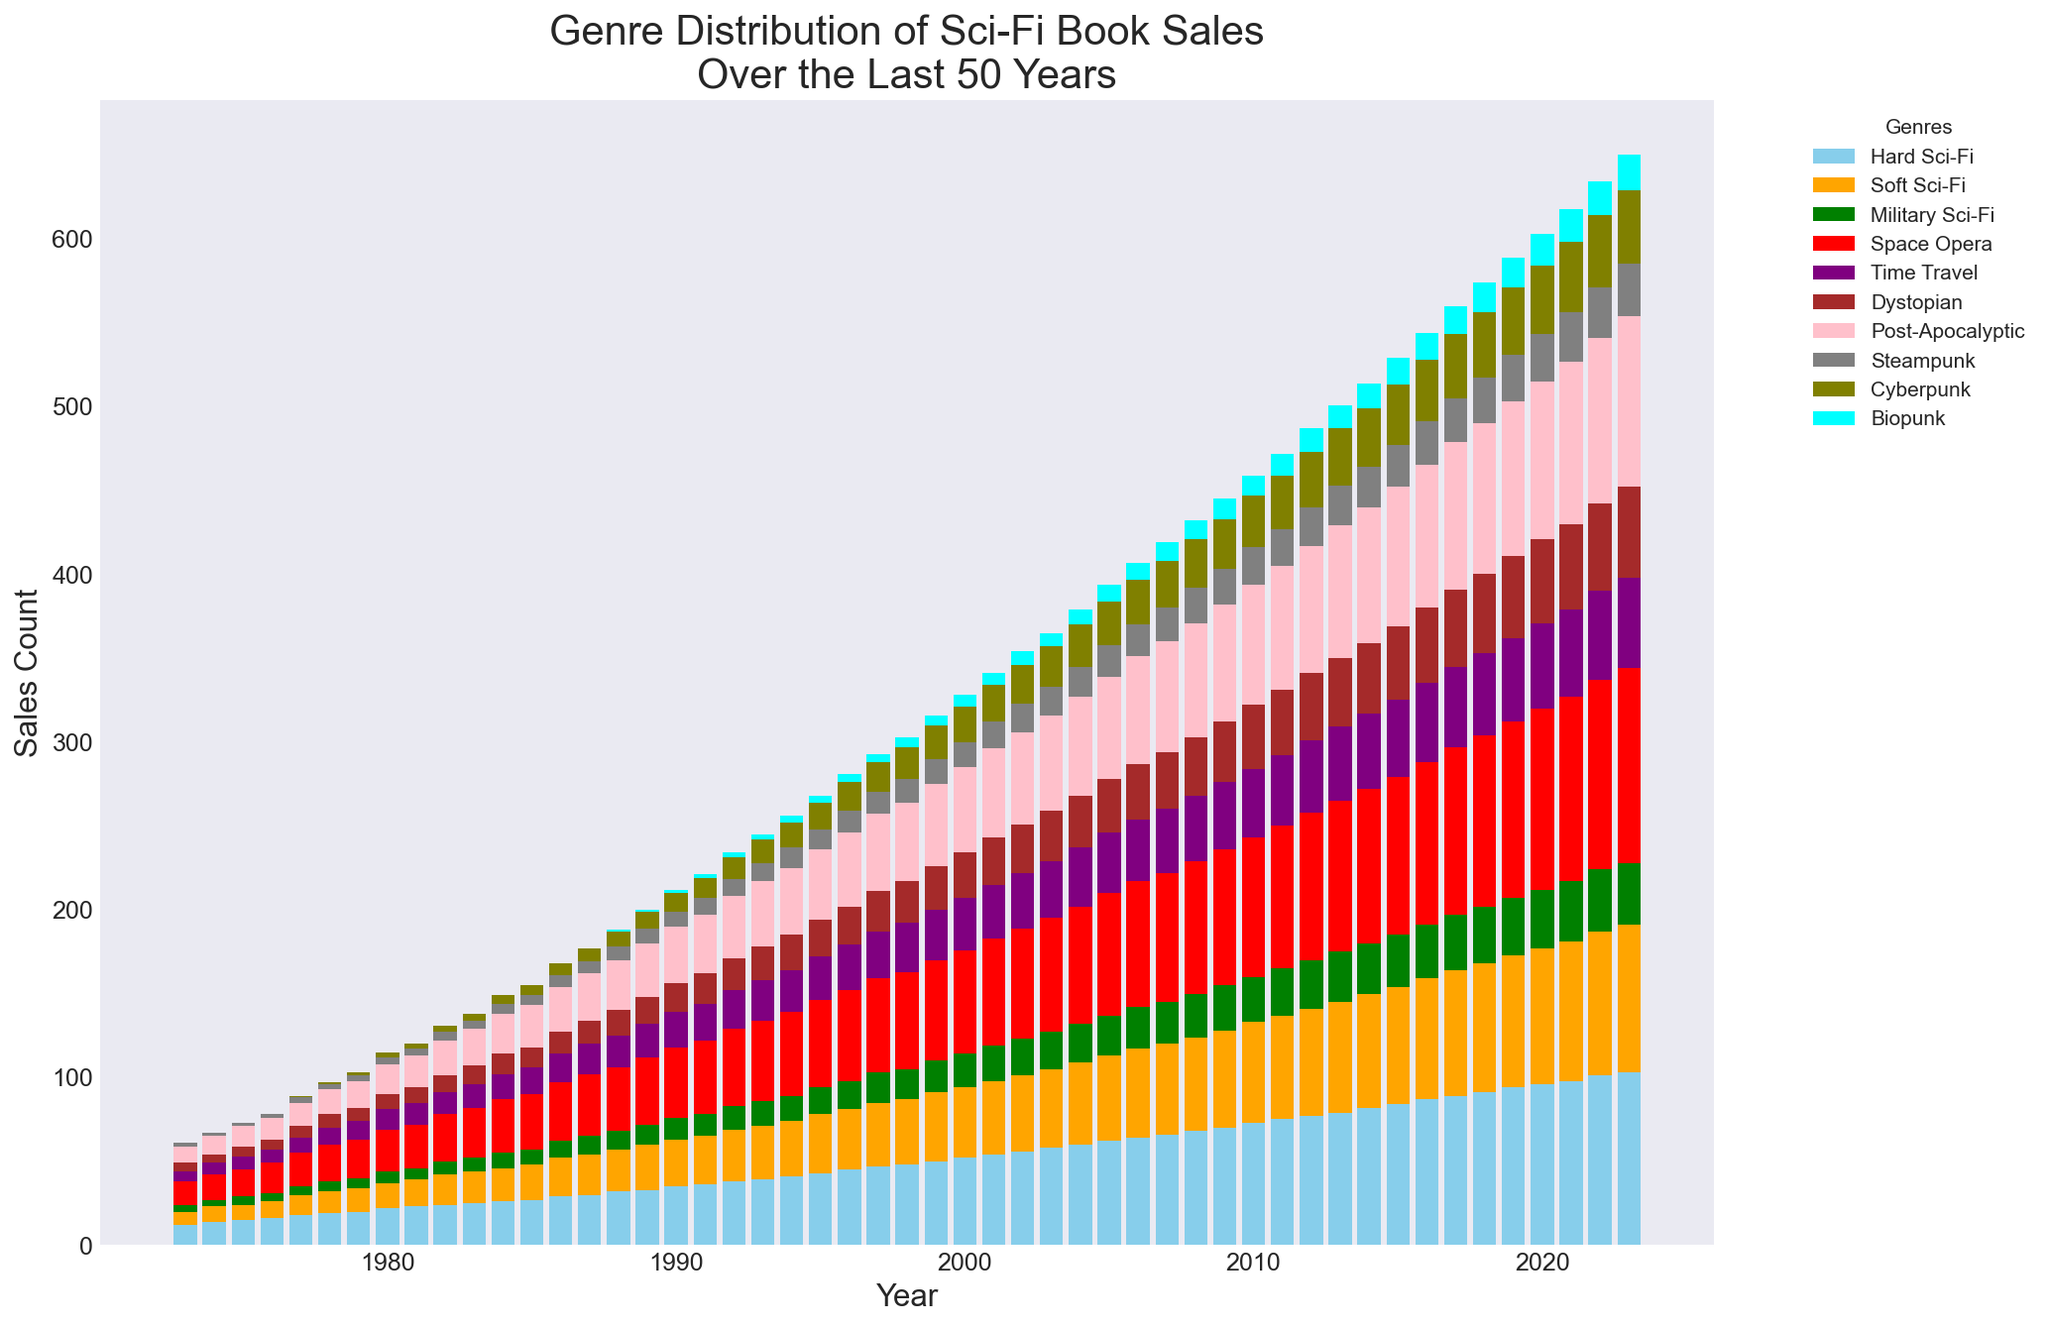What's the most popular genre in 2023? The bar representing "Space Opera" is the highest among all genres for the year 2023.
Answer: Space Opera How many more "Cyberpunk" books were sold in 2022 compared to 1988? The "Cyberpunk" bar in 2022 is at 43, while in 1988 it is at 9. So, the difference is 43 - 9 = 34.
Answer: 34 Which genre had the least sales in 1980? The least visible bar in 1980 is "Biopunk", which has zero sales.
Answer: Biopunk In which year did "Dystopian" surpass 20 sales for the first time? The bars for "Dystopian" surpass 20 in 1993 when the sales hit 20 for the first time.
Answer: 1993 Compare the "Hard Sci-Fi" and "Soft Sci-Fi" sales in 1990. Which is higher and by how much? The "Hard Sci-Fi" bar in 1990 is at 35, and the "Soft Sci-Fi" bar is at 28. The difference is 35 - 28 = 7.
Answer: Hard Sci-Fi, by 7 What's the cumulative number of "Space Opera" and "Time Travel" sales in 2018? The "Space Opera" sales in 2018 are 102, and "Time Travel" sales are 49. So, the cumulative number is 102 + 49 = 151.
Answer: 151 How did the "Post-Apocalyptic" genre sales change from 1973 to 2023? In 1973, "Post-Apocalyptic" sales were 10, and in 2023, they were 102. The change is 102 - 10 = 92.
Answer: Increased by 92 Which genre had the steepest growth from 2008 to 2018? For each genre, the sales difference between 2008 and 2018 are checked:
  - "Hard Sci-Fi": 91 - 68 = 23
  - "Soft Sci-Fi": 77 - 56 = 21
  - "Military Sci-Fi": 34 - 26 = 8
  - "Space Opera": 102 - 79 = 23
  - "Time Travel": 49 - 39 = 10
  - "Dystopian": 47 - 35 = 12
  - "Post-Apocalyptic": 90 - 68 = 22
  - "Steampunk": 27 - 21 = 6
  - "Cyberpunk": 39 - 29 = 10
  - "Biopunk": 18 - 11 = 7
Therefore, "Hard Sci-Fi" and "Space Opera" both grew by 23 sales.
Answer: Hard Sci-Fi and Space Opera Between 2015 and 2016, which genre's sales increased the most? "Hard Sci-Fi" increased from 84 to 87 (difference of 3), "Soft Sci-Fi" from 70 to 72 (difference of 2), "Military Sci-Fi" from 31 to 32 (difference of 1), "Space Opera" from 94 to 97 (difference of 3), "Time Travel" from 46 to 47 (difference of 1), "Dystopian" from 44 to 45 (difference of 1), "Post-Apocalyptic" from 83 to 85 (difference of 2), "Steampunk" from 25 to 26 (difference of 1), "Cyberpunk" from 36 to 37 (difference of 1), "Biopunk" from 16 to 16 (no change). "Hard Sci-Fi" and "Space Opera" both increased the most by 3.
Answer: Hard Sci-Fi and Space Opera If you combine sales of "Steampunk" and "Cyberpunk" in 1978, what percentage of the total sales does this represent for that year? Sales for "Steampunk" in 1978: 3; for "Cyberpunk": 1; combined: 3 + 1 = 4. The total sales for all genres in 1978 are: 
  19 + 13 + 6 + 22 + 10 + 8 + 15 + 3 + 1 + 0 = 97.
The percentage is (4 / 97) * 100 ≈ 4.12%.
Answer: 4.12% 